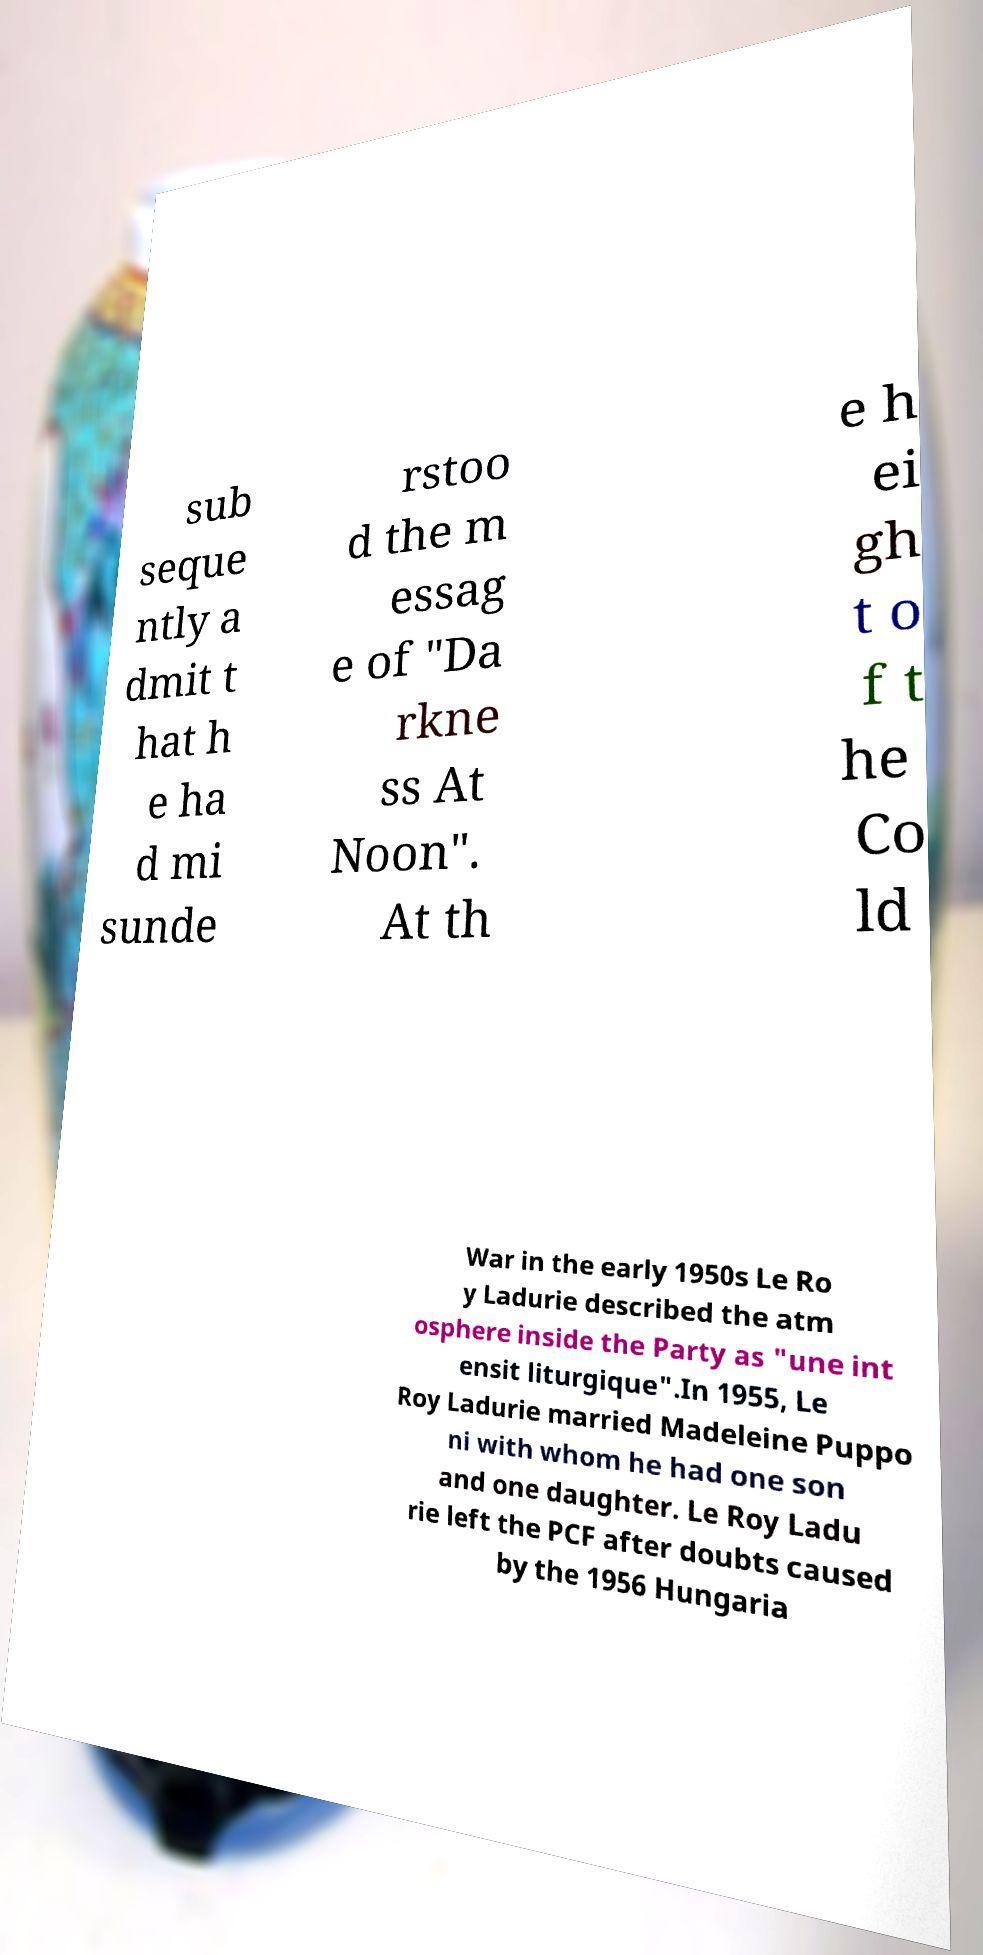There's text embedded in this image that I need extracted. Can you transcribe it verbatim? sub seque ntly a dmit t hat h e ha d mi sunde rstoo d the m essag e of "Da rkne ss At Noon". At th e h ei gh t o f t he Co ld War in the early 1950s Le Ro y Ladurie described the atm osphere inside the Party as "une int ensit liturgique".In 1955, Le Roy Ladurie married Madeleine Puppo ni with whom he had one son and one daughter. Le Roy Ladu rie left the PCF after doubts caused by the 1956 Hungaria 